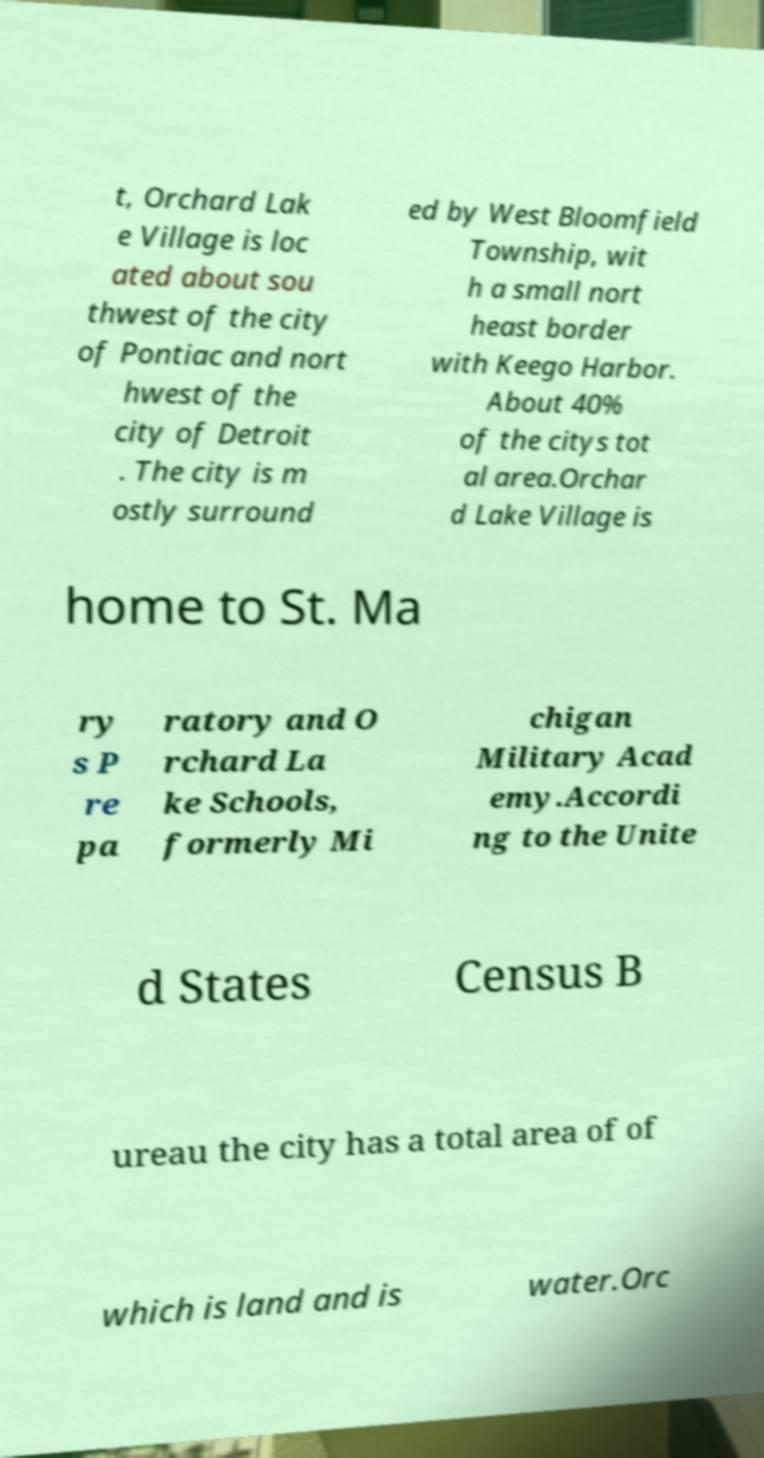Please read and relay the text visible in this image. What does it say? t, Orchard Lak e Village is loc ated about sou thwest of the city of Pontiac and nort hwest of the city of Detroit . The city is m ostly surround ed by West Bloomfield Township, wit h a small nort heast border with Keego Harbor. About 40% of the citys tot al area.Orchar d Lake Village is home to St. Ma ry s P re pa ratory and O rchard La ke Schools, formerly Mi chigan Military Acad emy.Accordi ng to the Unite d States Census B ureau the city has a total area of of which is land and is water.Orc 